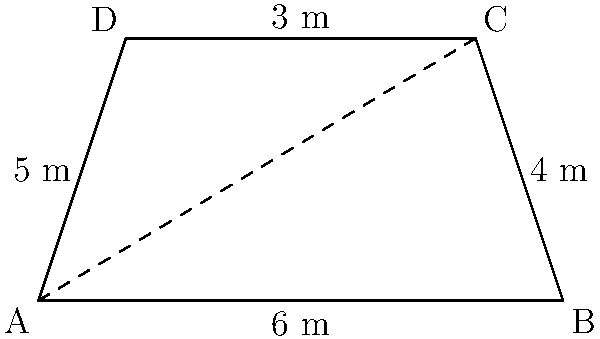As a tech enthusiast organizing a meetup on solar energy innovations, you're showcasing a new trapezoidal solar panel design. The panel has parallel sides of 3 m and 6 m, with non-parallel sides measuring 4 m and 5 m. What is the area of this solar panel in square meters? To calculate the area of the trapezoidal solar panel, we'll use the following steps:

1) The formula for the area of a trapezoid is:

   $$A = \frac{1}{2}(b_1 + b_2)h$$

   where $A$ is the area, $b_1$ and $b_2$ are the lengths of the parallel sides, and $h$ is the height.

2) We know $b_1 = 3$ m and $b_2 = 6$ m, but we need to find $h$.

3) To find $h$, we can use the Pythagorean theorem on the right triangle formed by the height and half the difference of the parallel sides:

   $$h^2 + (\frac{6-3}{2})^2 = 4^2$$

4) Simplify:
   $$h^2 + 1.5^2 = 4^2$$
   $$h^2 + 2.25 = 16$$

5) Solve for $h$:
   $$h^2 = 13.75$$
   $$h = \sqrt{13.75} \approx 3.708$$

6) Now we can calculate the area:

   $$A = \frac{1}{2}(3 + 6) \cdot 3.708$$
   $$A = \frac{1}{2}(9) \cdot 3.708$$
   $$A = 4.5 \cdot 3.708$$
   $$A \approx 16.686$$

7) Rounding to two decimal places:
   $$A \approx 16.69 \text{ m}^2$$
Answer: 16.69 m² 